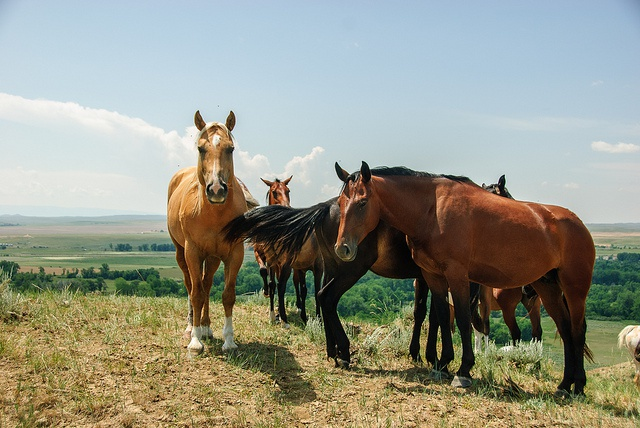Describe the objects in this image and their specific colors. I can see horse in darkgray, black, maroon, and brown tones, horse in darkgray, maroon, black, and brown tones, horse in darkgray, black, gray, and maroon tones, horse in darkgray, black, maroon, brown, and olive tones, and horse in darkgray, olive, tan, and beige tones in this image. 